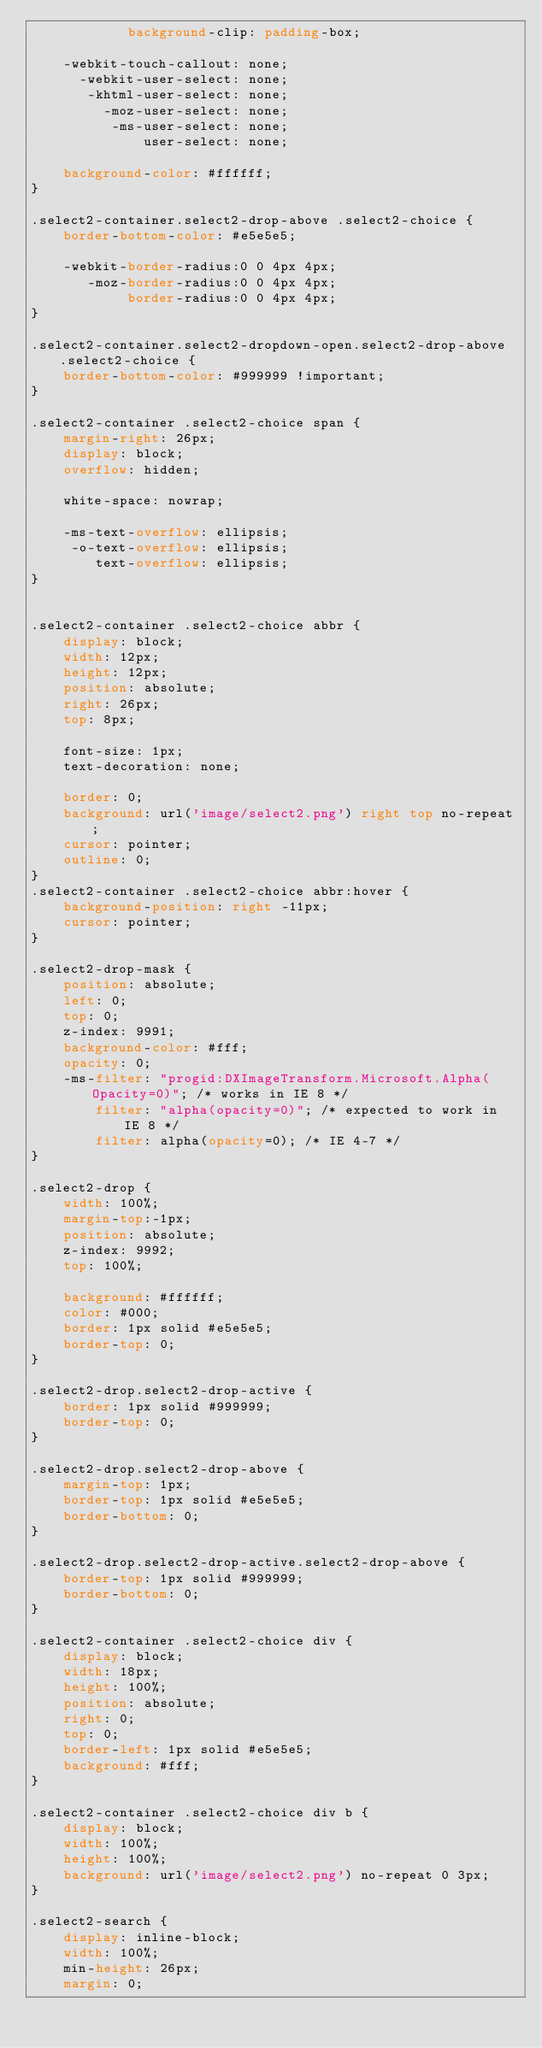Convert code to text. <code><loc_0><loc_0><loc_500><loc_500><_CSS_>            background-clip: padding-box;

    -webkit-touch-callout: none;
      -webkit-user-select: none;
       -khtml-user-select: none;
         -moz-user-select: none;
          -ms-user-select: none;
              user-select: none;

    background-color: #ffffff;
}

.select2-container.select2-drop-above .select2-choice {
    border-bottom-color: #e5e5e5;

    -webkit-border-radius:0 0 4px 4px;
       -moz-border-radius:0 0 4px 4px;
            border-radius:0 0 4px 4px;
}

.select2-container.select2-dropdown-open.select2-drop-above .select2-choice {
    border-bottom-color: #999999 !important;
}

.select2-container .select2-choice span {
    margin-right: 26px;
    display: block;
    overflow: hidden;

    white-space: nowrap;

    -ms-text-overflow: ellipsis;
     -o-text-overflow: ellipsis;
        text-overflow: ellipsis;
}


.select2-container .select2-choice abbr {
    display: block;
    width: 12px;
    height: 12px;
    position: absolute;
    right: 26px;
    top: 8px;

    font-size: 1px;
    text-decoration: none;

    border: 0;
    background: url('image/select2.png') right top no-repeat;
    cursor: pointer;
    outline: 0;
}
.select2-container .select2-choice abbr:hover {
    background-position: right -11px;
    cursor: pointer;
}

.select2-drop-mask {
    position: absolute;
    left: 0;
    top: 0;
    z-index: 9991;
    background-color: #fff;
    opacity: 0;
    -ms-filter: "progid:DXImageTransform.Microsoft.Alpha(Opacity=0)"; /* works in IE 8 */
        filter: "alpha(opacity=0)"; /* expected to work in IE 8 */
        filter: alpha(opacity=0); /* IE 4-7 */
}

.select2-drop {
    width: 100%;
    margin-top:-1px;
    position: absolute;
    z-index: 9992;
    top: 100%;

    background: #ffffff;
    color: #000;
    border: 1px solid #e5e5e5;
    border-top: 0;
}

.select2-drop.select2-drop-active {
    border: 1px solid #999999;
    border-top: 0;
}

.select2-drop.select2-drop-above {
    margin-top: 1px;
    border-top: 1px solid #e5e5e5;
    border-bottom: 0;
}

.select2-drop.select2-drop-active.select2-drop-above {
    border-top: 1px solid #999999;
    border-bottom: 0;
}

.select2-container .select2-choice div {
    display: block;
    width: 18px;
    height: 100%;
    position: absolute;
    right: 0;
    top: 0;
    border-left: 1px solid #e5e5e5;
    background: #fff;
}

.select2-container .select2-choice div b {
    display: block;
    width: 100%;
    height: 100%;
    background: url('image/select2.png') no-repeat 0 3px;
}

.select2-search {
    display: inline-block;
    width: 100%;
    min-height: 26px;
    margin: 0;</code> 